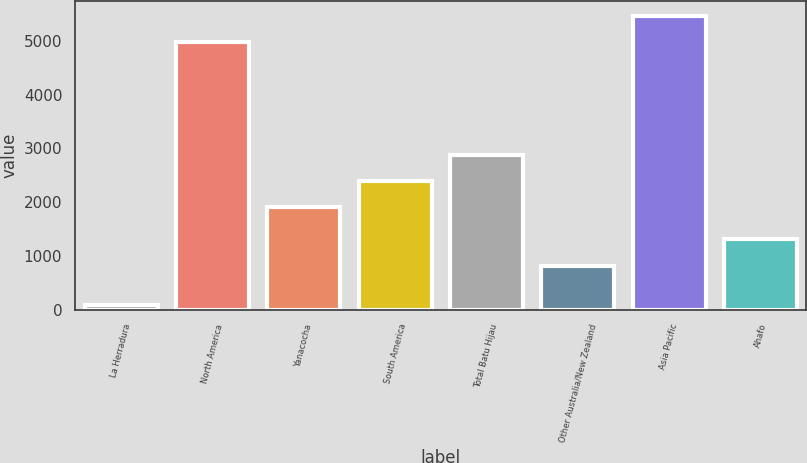Convert chart. <chart><loc_0><loc_0><loc_500><loc_500><bar_chart><fcel>La Herradura<fcel>North America<fcel>Yanacocha<fcel>South America<fcel>Total Batu Hijau<fcel>Other Australia/New Zealand<fcel>Asia Pacific<fcel>Ahafo<nl><fcel>90<fcel>4978<fcel>1902<fcel>2394.2<fcel>2886.4<fcel>819<fcel>5470.2<fcel>1311.2<nl></chart> 